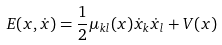<formula> <loc_0><loc_0><loc_500><loc_500>E ( x , \dot { x } ) = \frac { 1 } { 2 } \mu _ { k l } ( x ) \dot { x } _ { k } \dot { x } _ { l } + V ( x )</formula> 